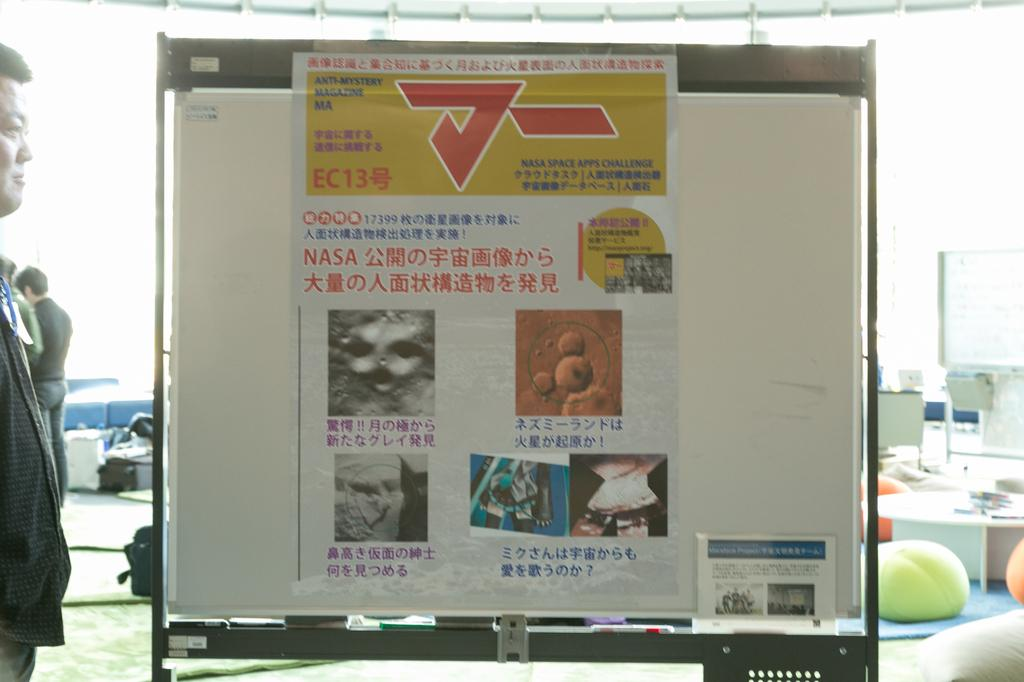<image>
Render a clear and concise summary of the photo. A sign on a white billboard reads Anti-Mystery Magazine 